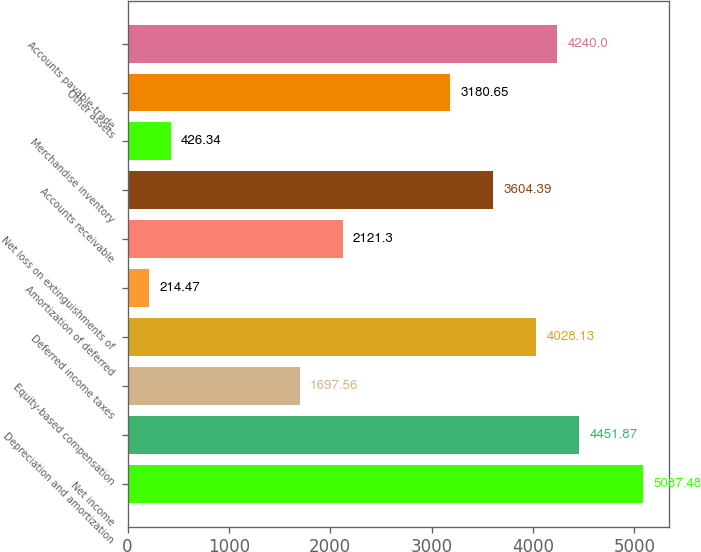Convert chart. <chart><loc_0><loc_0><loc_500><loc_500><bar_chart><fcel>Net income<fcel>Depreciation and amortization<fcel>Equity-based compensation<fcel>Deferred income taxes<fcel>Amortization of deferred<fcel>Net loss on extinguishments of<fcel>Accounts receivable<fcel>Merchandise inventory<fcel>Other assets<fcel>Accounts payable-trade<nl><fcel>5087.48<fcel>4451.87<fcel>1697.56<fcel>4028.13<fcel>214.47<fcel>2121.3<fcel>3604.39<fcel>426.34<fcel>3180.65<fcel>4240<nl></chart> 